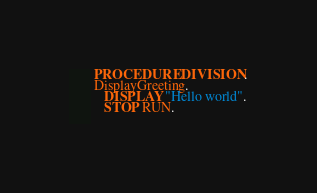<code> <loc_0><loc_0><loc_500><loc_500><_COBOL_>       PROCEDURE DIVISION.
       DisplayGreeting.
          DISPLAY "Hello world".
          STOP RUN.
                   
</code> 